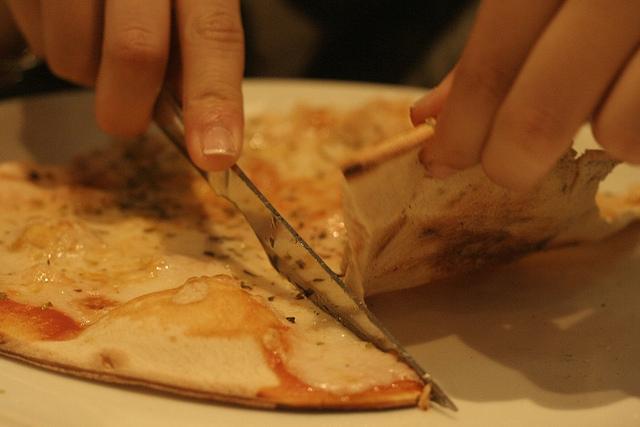What other utensil usually goes alongside the one shown?
Select the accurate response from the four choices given to answer the question.
Options: Axe, spatula, fork, ladle. Fork. 